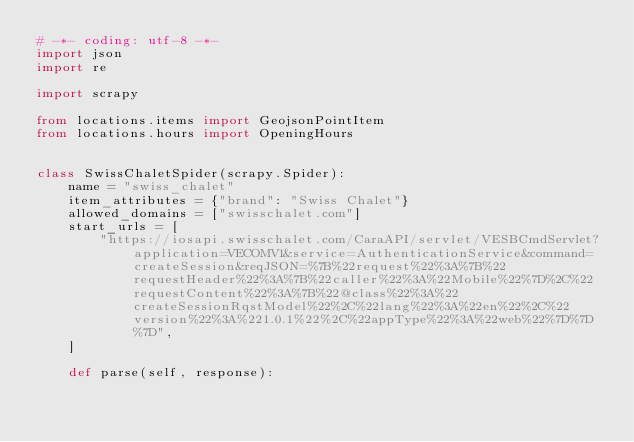<code> <loc_0><loc_0><loc_500><loc_500><_Python_># -*- coding: utf-8 -*-
import json
import re

import scrapy

from locations.items import GeojsonPointItem
from locations.hours import OpeningHours


class SwissChaletSpider(scrapy.Spider):
    name = "swiss_chalet"
    item_attributes = {"brand": "Swiss Chalet"}
    allowed_domains = ["swisschalet.com"]
    start_urls = [
        "https://iosapi.swisschalet.com/CaraAPI/servlet/VESBCmdServlet?application=VECOMV1&service=AuthenticationService&command=createSession&reqJSON=%7B%22request%22%3A%7B%22requestHeader%22%3A%7B%22caller%22%3A%22Mobile%22%7D%2C%22requestContent%22%3A%7B%22@class%22%3A%22createSessionRqstModel%22%2C%22lang%22%3A%22en%22%2C%22version%22%3A%221.0.1%22%2C%22appType%22%3A%22web%22%7D%7D%7D",
    ]

    def parse(self, response):</code> 